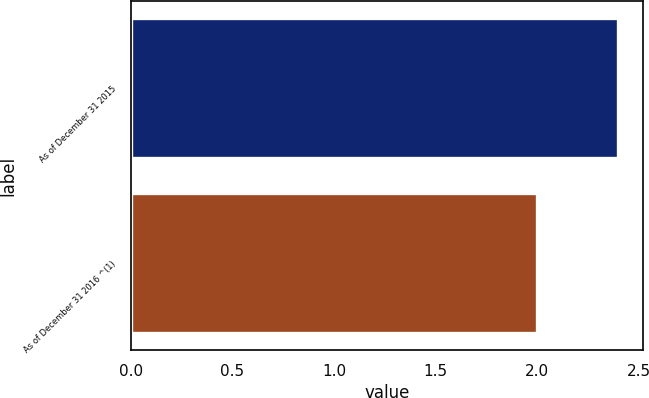Convert chart to OTSL. <chart><loc_0><loc_0><loc_500><loc_500><bar_chart><fcel>As of December 31 2015<fcel>As of December 31 2016 ^(1)<nl><fcel>2.4<fcel>2<nl></chart> 